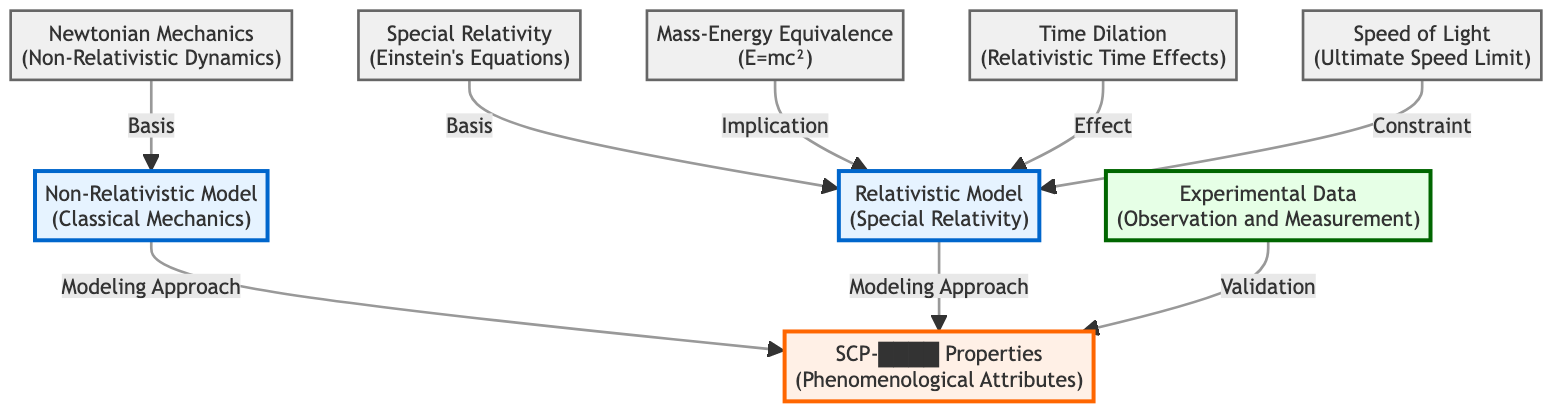What are the two types of models represented in the diagram? The diagram explicitly mentions two models: "Non-Relativistic Model (Classical Mechanics)" and "Relativistic Model (Special Relativity)" as distinct nodes.
Answer: Non-Relativistic Model, Relativistic Model Which concept is associated with mass-energy in the diagram? The diagram illustrates that "Mass-Energy Equivalence" is linked to the "Relativistic Model" as an implication, indicating its relevance to relativistic physics.
Answer: Mass-Energy Equivalence What is the ultimate speed limit according to the diagram? The diagram clearly states "Speed of Light" as a concept associated with constraints in the "Relativistic Model."
Answer: Speed of Light Count the number of concepts linked to the relativistic model. The diagram shows three concepts directly associated with the "Relativistic Model:" "Mass-Energy Equivalence," "Time Dilation," and "Speed Limit."
Answer: 3 What are the two bases for the models in the diagram? The diagram identifies "Newtonian Mechanics" as the basis for the Non-Relativistic Model, and "Special Relativity" as the basis for the Relativistic Model, linking each model to its foundational principles.
Answer: Newtonian Mechanics, Special Relativity How does experimental data validate SCP properties? In the diagram, "Experimental Data" is connected to "SCP-████ Properties" by being labeled as validation, indicating that observations and measurements support the understanding of these properties.
Answer: Validation Which concept refers to relativistic time effects? The diagram explicitly names "Time Dilation" as the concept that describes relativistic time effects associated with the "Relativistic Model."
Answer: Time Dilation How many edges are linked to the Non-Relativistic Model? There are two edges connecting to "Non-Relativistic Model" indicating its relationship with "SCP-████ Properties" and "Newtonian Mechanics," showing its direct connections in the structure.
Answer: 2 What effects does the relativistic model account for? The diagram associates the "Relativistic Model" with "Mass-Energy Equivalence" and "Time Dilation," implying that these are key effects explained within the context of that model.
Answer: Mass-Energy Equivalence, Time Dilation 